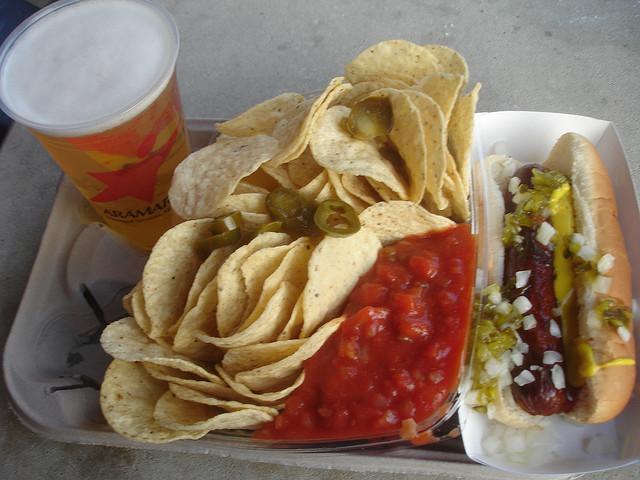How many hot dogs are in the photo?
Give a very brief answer. 1. How many hot dogs can you see?
Give a very brief answer. 1. 